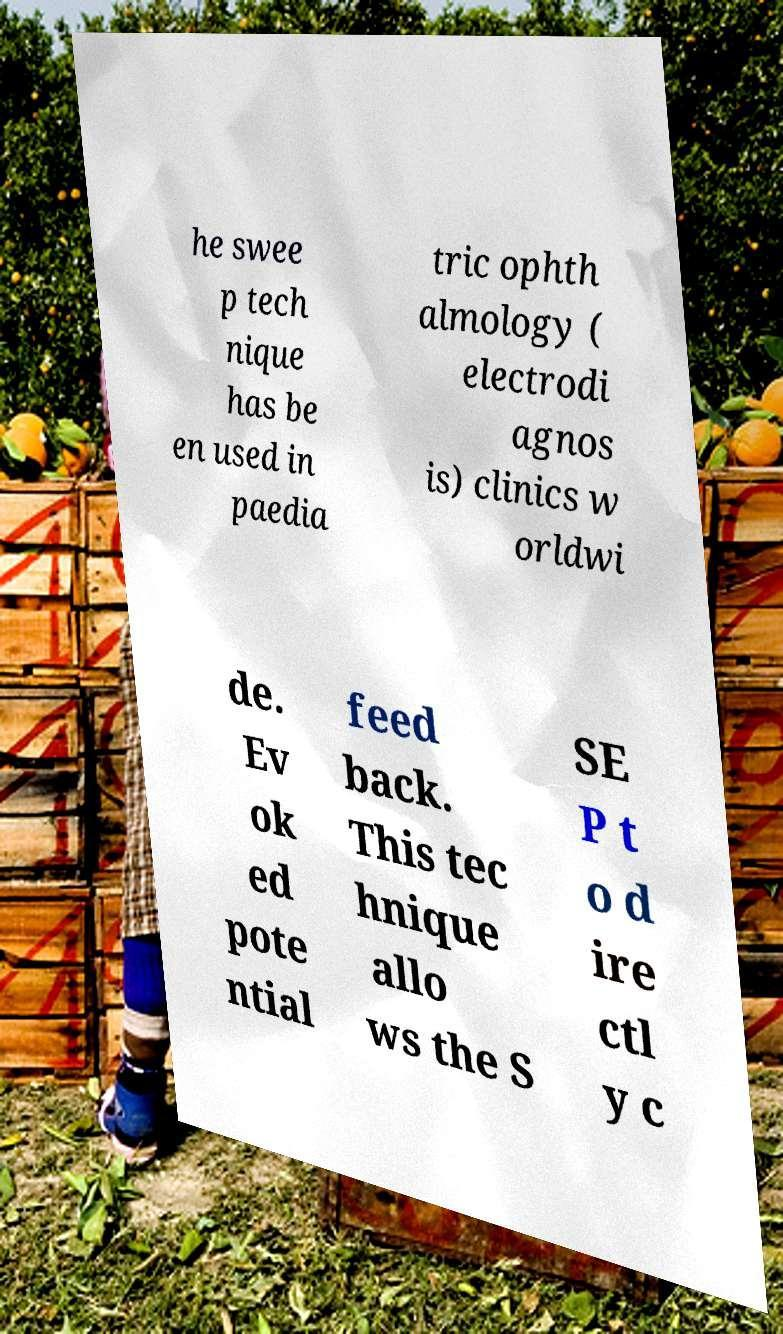Could you assist in decoding the text presented in this image and type it out clearly? he swee p tech nique has be en used in paedia tric ophth almology ( electrodi agnos is) clinics w orldwi de. Ev ok ed pote ntial feed back. This tec hnique allo ws the S SE P t o d ire ctl y c 